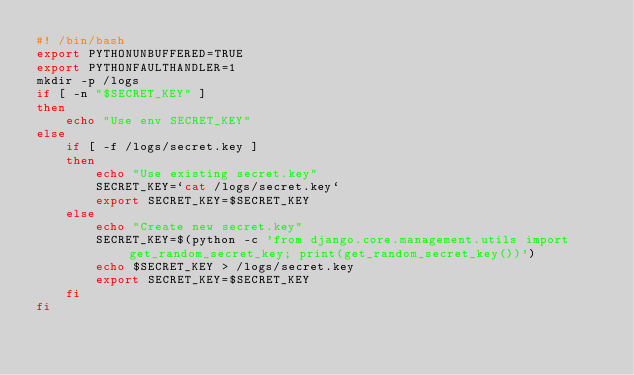Convert code to text. <code><loc_0><loc_0><loc_500><loc_500><_Bash_>#! /bin/bash
export PYTHONUNBUFFERED=TRUE
export PYTHONFAULTHANDLER=1
mkdir -p /logs
if [ -n "$SECRET_KEY" ]
then
    echo "Use env SECRET_KEY"
else 
    if [ -f /logs/secret.key ]
    then
        echo "Use existing secret.key"
        SECRET_KEY=`cat /logs/secret.key`
        export SECRET_KEY=$SECRET_KEY
    else
        echo "Create new secret.key"
        SECRET_KEY=$(python -c 'from django.core.management.utils import get_random_secret_key; print(get_random_secret_key())')
        echo $SECRET_KEY > /logs/secret.key
        export SECRET_KEY=$SECRET_KEY
    fi
fi
</code> 